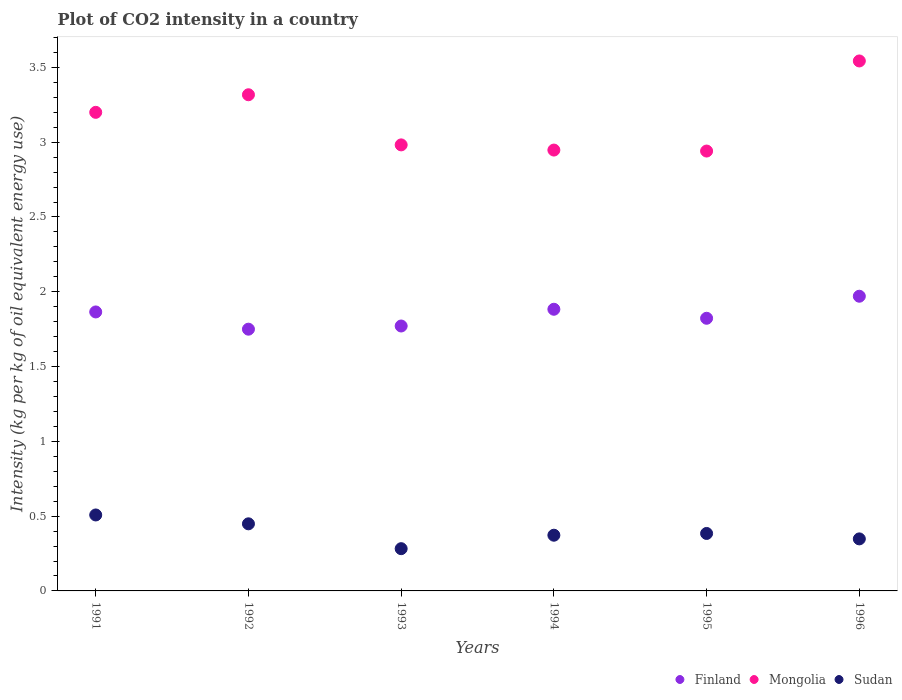How many different coloured dotlines are there?
Ensure brevity in your answer.  3. What is the CO2 intensity in in Sudan in 1992?
Your answer should be compact. 0.45. Across all years, what is the maximum CO2 intensity in in Finland?
Ensure brevity in your answer.  1.97. Across all years, what is the minimum CO2 intensity in in Mongolia?
Ensure brevity in your answer.  2.94. What is the total CO2 intensity in in Finland in the graph?
Your answer should be compact. 11.06. What is the difference between the CO2 intensity in in Sudan in 1991 and that in 1996?
Make the answer very short. 0.16. What is the difference between the CO2 intensity in in Mongolia in 1994 and the CO2 intensity in in Finland in 1996?
Your answer should be compact. 0.98. What is the average CO2 intensity in in Mongolia per year?
Provide a succinct answer. 3.15. In the year 1992, what is the difference between the CO2 intensity in in Mongolia and CO2 intensity in in Finland?
Your response must be concise. 1.57. In how many years, is the CO2 intensity in in Sudan greater than 2.8 kg?
Your answer should be very brief. 0. What is the ratio of the CO2 intensity in in Sudan in 1993 to that in 1995?
Give a very brief answer. 0.74. What is the difference between the highest and the second highest CO2 intensity in in Mongolia?
Keep it short and to the point. 0.23. What is the difference between the highest and the lowest CO2 intensity in in Finland?
Give a very brief answer. 0.22. In how many years, is the CO2 intensity in in Mongolia greater than the average CO2 intensity in in Mongolia taken over all years?
Offer a terse response. 3. Does the CO2 intensity in in Mongolia monotonically increase over the years?
Give a very brief answer. No. How many years are there in the graph?
Offer a terse response. 6. Does the graph contain grids?
Keep it short and to the point. No. How are the legend labels stacked?
Your answer should be very brief. Horizontal. What is the title of the graph?
Your answer should be compact. Plot of CO2 intensity in a country. What is the label or title of the X-axis?
Keep it short and to the point. Years. What is the label or title of the Y-axis?
Provide a succinct answer. Intensity (kg per kg of oil equivalent energy use). What is the Intensity (kg per kg of oil equivalent energy use) of Finland in 1991?
Offer a terse response. 1.87. What is the Intensity (kg per kg of oil equivalent energy use) in Mongolia in 1991?
Your response must be concise. 3.2. What is the Intensity (kg per kg of oil equivalent energy use) in Sudan in 1991?
Your answer should be compact. 0.51. What is the Intensity (kg per kg of oil equivalent energy use) in Finland in 1992?
Provide a succinct answer. 1.75. What is the Intensity (kg per kg of oil equivalent energy use) in Mongolia in 1992?
Give a very brief answer. 3.32. What is the Intensity (kg per kg of oil equivalent energy use) of Sudan in 1992?
Provide a short and direct response. 0.45. What is the Intensity (kg per kg of oil equivalent energy use) of Finland in 1993?
Offer a very short reply. 1.77. What is the Intensity (kg per kg of oil equivalent energy use) of Mongolia in 1993?
Provide a succinct answer. 2.98. What is the Intensity (kg per kg of oil equivalent energy use) of Sudan in 1993?
Keep it short and to the point. 0.28. What is the Intensity (kg per kg of oil equivalent energy use) in Finland in 1994?
Your answer should be compact. 1.88. What is the Intensity (kg per kg of oil equivalent energy use) of Mongolia in 1994?
Offer a very short reply. 2.95. What is the Intensity (kg per kg of oil equivalent energy use) in Sudan in 1994?
Make the answer very short. 0.37. What is the Intensity (kg per kg of oil equivalent energy use) of Finland in 1995?
Your answer should be compact. 1.82. What is the Intensity (kg per kg of oil equivalent energy use) of Mongolia in 1995?
Ensure brevity in your answer.  2.94. What is the Intensity (kg per kg of oil equivalent energy use) of Sudan in 1995?
Provide a short and direct response. 0.38. What is the Intensity (kg per kg of oil equivalent energy use) of Finland in 1996?
Offer a terse response. 1.97. What is the Intensity (kg per kg of oil equivalent energy use) of Mongolia in 1996?
Provide a succinct answer. 3.54. What is the Intensity (kg per kg of oil equivalent energy use) in Sudan in 1996?
Give a very brief answer. 0.35. Across all years, what is the maximum Intensity (kg per kg of oil equivalent energy use) of Finland?
Provide a short and direct response. 1.97. Across all years, what is the maximum Intensity (kg per kg of oil equivalent energy use) of Mongolia?
Give a very brief answer. 3.54. Across all years, what is the maximum Intensity (kg per kg of oil equivalent energy use) in Sudan?
Keep it short and to the point. 0.51. Across all years, what is the minimum Intensity (kg per kg of oil equivalent energy use) in Finland?
Provide a short and direct response. 1.75. Across all years, what is the minimum Intensity (kg per kg of oil equivalent energy use) of Mongolia?
Your answer should be very brief. 2.94. Across all years, what is the minimum Intensity (kg per kg of oil equivalent energy use) in Sudan?
Offer a very short reply. 0.28. What is the total Intensity (kg per kg of oil equivalent energy use) in Finland in the graph?
Make the answer very short. 11.06. What is the total Intensity (kg per kg of oil equivalent energy use) of Mongolia in the graph?
Keep it short and to the point. 18.93. What is the total Intensity (kg per kg of oil equivalent energy use) of Sudan in the graph?
Your answer should be compact. 2.34. What is the difference between the Intensity (kg per kg of oil equivalent energy use) of Finland in 1991 and that in 1992?
Offer a terse response. 0.12. What is the difference between the Intensity (kg per kg of oil equivalent energy use) of Mongolia in 1991 and that in 1992?
Your response must be concise. -0.12. What is the difference between the Intensity (kg per kg of oil equivalent energy use) in Sudan in 1991 and that in 1992?
Your answer should be compact. 0.06. What is the difference between the Intensity (kg per kg of oil equivalent energy use) in Finland in 1991 and that in 1993?
Make the answer very short. 0.09. What is the difference between the Intensity (kg per kg of oil equivalent energy use) of Mongolia in 1991 and that in 1993?
Make the answer very short. 0.22. What is the difference between the Intensity (kg per kg of oil equivalent energy use) in Sudan in 1991 and that in 1993?
Make the answer very short. 0.23. What is the difference between the Intensity (kg per kg of oil equivalent energy use) of Finland in 1991 and that in 1994?
Give a very brief answer. -0.02. What is the difference between the Intensity (kg per kg of oil equivalent energy use) of Mongolia in 1991 and that in 1994?
Your answer should be compact. 0.25. What is the difference between the Intensity (kg per kg of oil equivalent energy use) in Sudan in 1991 and that in 1994?
Your response must be concise. 0.14. What is the difference between the Intensity (kg per kg of oil equivalent energy use) of Finland in 1991 and that in 1995?
Provide a succinct answer. 0.04. What is the difference between the Intensity (kg per kg of oil equivalent energy use) of Mongolia in 1991 and that in 1995?
Keep it short and to the point. 0.26. What is the difference between the Intensity (kg per kg of oil equivalent energy use) in Sudan in 1991 and that in 1995?
Make the answer very short. 0.12. What is the difference between the Intensity (kg per kg of oil equivalent energy use) in Finland in 1991 and that in 1996?
Your answer should be very brief. -0.1. What is the difference between the Intensity (kg per kg of oil equivalent energy use) of Mongolia in 1991 and that in 1996?
Your response must be concise. -0.34. What is the difference between the Intensity (kg per kg of oil equivalent energy use) of Sudan in 1991 and that in 1996?
Make the answer very short. 0.16. What is the difference between the Intensity (kg per kg of oil equivalent energy use) of Finland in 1992 and that in 1993?
Provide a short and direct response. -0.02. What is the difference between the Intensity (kg per kg of oil equivalent energy use) in Mongolia in 1992 and that in 1993?
Keep it short and to the point. 0.34. What is the difference between the Intensity (kg per kg of oil equivalent energy use) of Sudan in 1992 and that in 1993?
Provide a short and direct response. 0.17. What is the difference between the Intensity (kg per kg of oil equivalent energy use) of Finland in 1992 and that in 1994?
Your answer should be very brief. -0.13. What is the difference between the Intensity (kg per kg of oil equivalent energy use) of Mongolia in 1992 and that in 1994?
Ensure brevity in your answer.  0.37. What is the difference between the Intensity (kg per kg of oil equivalent energy use) in Sudan in 1992 and that in 1994?
Provide a succinct answer. 0.08. What is the difference between the Intensity (kg per kg of oil equivalent energy use) of Finland in 1992 and that in 1995?
Your answer should be very brief. -0.07. What is the difference between the Intensity (kg per kg of oil equivalent energy use) in Mongolia in 1992 and that in 1995?
Provide a short and direct response. 0.38. What is the difference between the Intensity (kg per kg of oil equivalent energy use) of Sudan in 1992 and that in 1995?
Offer a very short reply. 0.06. What is the difference between the Intensity (kg per kg of oil equivalent energy use) in Finland in 1992 and that in 1996?
Give a very brief answer. -0.22. What is the difference between the Intensity (kg per kg of oil equivalent energy use) in Mongolia in 1992 and that in 1996?
Provide a short and direct response. -0.23. What is the difference between the Intensity (kg per kg of oil equivalent energy use) in Sudan in 1992 and that in 1996?
Provide a succinct answer. 0.1. What is the difference between the Intensity (kg per kg of oil equivalent energy use) of Finland in 1993 and that in 1994?
Provide a short and direct response. -0.11. What is the difference between the Intensity (kg per kg of oil equivalent energy use) in Mongolia in 1993 and that in 1994?
Offer a very short reply. 0.03. What is the difference between the Intensity (kg per kg of oil equivalent energy use) of Sudan in 1993 and that in 1994?
Make the answer very short. -0.09. What is the difference between the Intensity (kg per kg of oil equivalent energy use) in Finland in 1993 and that in 1995?
Your answer should be very brief. -0.05. What is the difference between the Intensity (kg per kg of oil equivalent energy use) in Mongolia in 1993 and that in 1995?
Ensure brevity in your answer.  0.04. What is the difference between the Intensity (kg per kg of oil equivalent energy use) of Sudan in 1993 and that in 1995?
Keep it short and to the point. -0.1. What is the difference between the Intensity (kg per kg of oil equivalent energy use) of Finland in 1993 and that in 1996?
Your response must be concise. -0.2. What is the difference between the Intensity (kg per kg of oil equivalent energy use) of Mongolia in 1993 and that in 1996?
Keep it short and to the point. -0.56. What is the difference between the Intensity (kg per kg of oil equivalent energy use) of Sudan in 1993 and that in 1996?
Your answer should be compact. -0.07. What is the difference between the Intensity (kg per kg of oil equivalent energy use) in Finland in 1994 and that in 1995?
Offer a very short reply. 0.06. What is the difference between the Intensity (kg per kg of oil equivalent energy use) of Mongolia in 1994 and that in 1995?
Give a very brief answer. 0.01. What is the difference between the Intensity (kg per kg of oil equivalent energy use) of Sudan in 1994 and that in 1995?
Offer a terse response. -0.01. What is the difference between the Intensity (kg per kg of oil equivalent energy use) in Finland in 1994 and that in 1996?
Give a very brief answer. -0.09. What is the difference between the Intensity (kg per kg of oil equivalent energy use) of Mongolia in 1994 and that in 1996?
Offer a very short reply. -0.6. What is the difference between the Intensity (kg per kg of oil equivalent energy use) of Sudan in 1994 and that in 1996?
Ensure brevity in your answer.  0.02. What is the difference between the Intensity (kg per kg of oil equivalent energy use) of Finland in 1995 and that in 1996?
Your response must be concise. -0.15. What is the difference between the Intensity (kg per kg of oil equivalent energy use) in Mongolia in 1995 and that in 1996?
Offer a very short reply. -0.6. What is the difference between the Intensity (kg per kg of oil equivalent energy use) in Sudan in 1995 and that in 1996?
Provide a succinct answer. 0.04. What is the difference between the Intensity (kg per kg of oil equivalent energy use) of Finland in 1991 and the Intensity (kg per kg of oil equivalent energy use) of Mongolia in 1992?
Offer a very short reply. -1.45. What is the difference between the Intensity (kg per kg of oil equivalent energy use) of Finland in 1991 and the Intensity (kg per kg of oil equivalent energy use) of Sudan in 1992?
Your answer should be compact. 1.42. What is the difference between the Intensity (kg per kg of oil equivalent energy use) of Mongolia in 1991 and the Intensity (kg per kg of oil equivalent energy use) of Sudan in 1992?
Give a very brief answer. 2.75. What is the difference between the Intensity (kg per kg of oil equivalent energy use) in Finland in 1991 and the Intensity (kg per kg of oil equivalent energy use) in Mongolia in 1993?
Keep it short and to the point. -1.12. What is the difference between the Intensity (kg per kg of oil equivalent energy use) of Finland in 1991 and the Intensity (kg per kg of oil equivalent energy use) of Sudan in 1993?
Provide a short and direct response. 1.58. What is the difference between the Intensity (kg per kg of oil equivalent energy use) in Mongolia in 1991 and the Intensity (kg per kg of oil equivalent energy use) in Sudan in 1993?
Keep it short and to the point. 2.92. What is the difference between the Intensity (kg per kg of oil equivalent energy use) of Finland in 1991 and the Intensity (kg per kg of oil equivalent energy use) of Mongolia in 1994?
Your answer should be compact. -1.08. What is the difference between the Intensity (kg per kg of oil equivalent energy use) of Finland in 1991 and the Intensity (kg per kg of oil equivalent energy use) of Sudan in 1994?
Offer a terse response. 1.49. What is the difference between the Intensity (kg per kg of oil equivalent energy use) of Mongolia in 1991 and the Intensity (kg per kg of oil equivalent energy use) of Sudan in 1994?
Provide a succinct answer. 2.83. What is the difference between the Intensity (kg per kg of oil equivalent energy use) in Finland in 1991 and the Intensity (kg per kg of oil equivalent energy use) in Mongolia in 1995?
Keep it short and to the point. -1.08. What is the difference between the Intensity (kg per kg of oil equivalent energy use) of Finland in 1991 and the Intensity (kg per kg of oil equivalent energy use) of Sudan in 1995?
Give a very brief answer. 1.48. What is the difference between the Intensity (kg per kg of oil equivalent energy use) of Mongolia in 1991 and the Intensity (kg per kg of oil equivalent energy use) of Sudan in 1995?
Provide a succinct answer. 2.82. What is the difference between the Intensity (kg per kg of oil equivalent energy use) of Finland in 1991 and the Intensity (kg per kg of oil equivalent energy use) of Mongolia in 1996?
Keep it short and to the point. -1.68. What is the difference between the Intensity (kg per kg of oil equivalent energy use) of Finland in 1991 and the Intensity (kg per kg of oil equivalent energy use) of Sudan in 1996?
Make the answer very short. 1.52. What is the difference between the Intensity (kg per kg of oil equivalent energy use) in Mongolia in 1991 and the Intensity (kg per kg of oil equivalent energy use) in Sudan in 1996?
Keep it short and to the point. 2.85. What is the difference between the Intensity (kg per kg of oil equivalent energy use) in Finland in 1992 and the Intensity (kg per kg of oil equivalent energy use) in Mongolia in 1993?
Your response must be concise. -1.23. What is the difference between the Intensity (kg per kg of oil equivalent energy use) in Finland in 1992 and the Intensity (kg per kg of oil equivalent energy use) in Sudan in 1993?
Your response must be concise. 1.47. What is the difference between the Intensity (kg per kg of oil equivalent energy use) of Mongolia in 1992 and the Intensity (kg per kg of oil equivalent energy use) of Sudan in 1993?
Provide a short and direct response. 3.03. What is the difference between the Intensity (kg per kg of oil equivalent energy use) of Finland in 1992 and the Intensity (kg per kg of oil equivalent energy use) of Mongolia in 1994?
Give a very brief answer. -1.2. What is the difference between the Intensity (kg per kg of oil equivalent energy use) in Finland in 1992 and the Intensity (kg per kg of oil equivalent energy use) in Sudan in 1994?
Your response must be concise. 1.38. What is the difference between the Intensity (kg per kg of oil equivalent energy use) of Mongolia in 1992 and the Intensity (kg per kg of oil equivalent energy use) of Sudan in 1994?
Give a very brief answer. 2.94. What is the difference between the Intensity (kg per kg of oil equivalent energy use) of Finland in 1992 and the Intensity (kg per kg of oil equivalent energy use) of Mongolia in 1995?
Ensure brevity in your answer.  -1.19. What is the difference between the Intensity (kg per kg of oil equivalent energy use) of Finland in 1992 and the Intensity (kg per kg of oil equivalent energy use) of Sudan in 1995?
Provide a succinct answer. 1.37. What is the difference between the Intensity (kg per kg of oil equivalent energy use) of Mongolia in 1992 and the Intensity (kg per kg of oil equivalent energy use) of Sudan in 1995?
Provide a short and direct response. 2.93. What is the difference between the Intensity (kg per kg of oil equivalent energy use) of Finland in 1992 and the Intensity (kg per kg of oil equivalent energy use) of Mongolia in 1996?
Offer a terse response. -1.79. What is the difference between the Intensity (kg per kg of oil equivalent energy use) in Finland in 1992 and the Intensity (kg per kg of oil equivalent energy use) in Sudan in 1996?
Make the answer very short. 1.4. What is the difference between the Intensity (kg per kg of oil equivalent energy use) of Mongolia in 1992 and the Intensity (kg per kg of oil equivalent energy use) of Sudan in 1996?
Your answer should be very brief. 2.97. What is the difference between the Intensity (kg per kg of oil equivalent energy use) in Finland in 1993 and the Intensity (kg per kg of oil equivalent energy use) in Mongolia in 1994?
Give a very brief answer. -1.18. What is the difference between the Intensity (kg per kg of oil equivalent energy use) in Finland in 1993 and the Intensity (kg per kg of oil equivalent energy use) in Sudan in 1994?
Ensure brevity in your answer.  1.4. What is the difference between the Intensity (kg per kg of oil equivalent energy use) of Mongolia in 1993 and the Intensity (kg per kg of oil equivalent energy use) of Sudan in 1994?
Your answer should be very brief. 2.61. What is the difference between the Intensity (kg per kg of oil equivalent energy use) of Finland in 1993 and the Intensity (kg per kg of oil equivalent energy use) of Mongolia in 1995?
Your response must be concise. -1.17. What is the difference between the Intensity (kg per kg of oil equivalent energy use) in Finland in 1993 and the Intensity (kg per kg of oil equivalent energy use) in Sudan in 1995?
Offer a very short reply. 1.39. What is the difference between the Intensity (kg per kg of oil equivalent energy use) of Mongolia in 1993 and the Intensity (kg per kg of oil equivalent energy use) of Sudan in 1995?
Make the answer very short. 2.6. What is the difference between the Intensity (kg per kg of oil equivalent energy use) of Finland in 1993 and the Intensity (kg per kg of oil equivalent energy use) of Mongolia in 1996?
Make the answer very short. -1.77. What is the difference between the Intensity (kg per kg of oil equivalent energy use) in Finland in 1993 and the Intensity (kg per kg of oil equivalent energy use) in Sudan in 1996?
Make the answer very short. 1.42. What is the difference between the Intensity (kg per kg of oil equivalent energy use) in Mongolia in 1993 and the Intensity (kg per kg of oil equivalent energy use) in Sudan in 1996?
Offer a very short reply. 2.63. What is the difference between the Intensity (kg per kg of oil equivalent energy use) in Finland in 1994 and the Intensity (kg per kg of oil equivalent energy use) in Mongolia in 1995?
Provide a short and direct response. -1.06. What is the difference between the Intensity (kg per kg of oil equivalent energy use) in Finland in 1994 and the Intensity (kg per kg of oil equivalent energy use) in Sudan in 1995?
Give a very brief answer. 1.5. What is the difference between the Intensity (kg per kg of oil equivalent energy use) of Mongolia in 1994 and the Intensity (kg per kg of oil equivalent energy use) of Sudan in 1995?
Make the answer very short. 2.56. What is the difference between the Intensity (kg per kg of oil equivalent energy use) in Finland in 1994 and the Intensity (kg per kg of oil equivalent energy use) in Mongolia in 1996?
Ensure brevity in your answer.  -1.66. What is the difference between the Intensity (kg per kg of oil equivalent energy use) in Finland in 1994 and the Intensity (kg per kg of oil equivalent energy use) in Sudan in 1996?
Provide a short and direct response. 1.54. What is the difference between the Intensity (kg per kg of oil equivalent energy use) of Mongolia in 1994 and the Intensity (kg per kg of oil equivalent energy use) of Sudan in 1996?
Your answer should be compact. 2.6. What is the difference between the Intensity (kg per kg of oil equivalent energy use) of Finland in 1995 and the Intensity (kg per kg of oil equivalent energy use) of Mongolia in 1996?
Offer a very short reply. -1.72. What is the difference between the Intensity (kg per kg of oil equivalent energy use) of Finland in 1995 and the Intensity (kg per kg of oil equivalent energy use) of Sudan in 1996?
Your response must be concise. 1.47. What is the difference between the Intensity (kg per kg of oil equivalent energy use) of Mongolia in 1995 and the Intensity (kg per kg of oil equivalent energy use) of Sudan in 1996?
Keep it short and to the point. 2.59. What is the average Intensity (kg per kg of oil equivalent energy use) in Finland per year?
Keep it short and to the point. 1.84. What is the average Intensity (kg per kg of oil equivalent energy use) in Mongolia per year?
Offer a very short reply. 3.15. What is the average Intensity (kg per kg of oil equivalent energy use) of Sudan per year?
Give a very brief answer. 0.39. In the year 1991, what is the difference between the Intensity (kg per kg of oil equivalent energy use) of Finland and Intensity (kg per kg of oil equivalent energy use) of Mongolia?
Keep it short and to the point. -1.33. In the year 1991, what is the difference between the Intensity (kg per kg of oil equivalent energy use) of Finland and Intensity (kg per kg of oil equivalent energy use) of Sudan?
Your answer should be compact. 1.36. In the year 1991, what is the difference between the Intensity (kg per kg of oil equivalent energy use) of Mongolia and Intensity (kg per kg of oil equivalent energy use) of Sudan?
Provide a succinct answer. 2.69. In the year 1992, what is the difference between the Intensity (kg per kg of oil equivalent energy use) of Finland and Intensity (kg per kg of oil equivalent energy use) of Mongolia?
Keep it short and to the point. -1.57. In the year 1992, what is the difference between the Intensity (kg per kg of oil equivalent energy use) of Finland and Intensity (kg per kg of oil equivalent energy use) of Sudan?
Offer a very short reply. 1.3. In the year 1992, what is the difference between the Intensity (kg per kg of oil equivalent energy use) of Mongolia and Intensity (kg per kg of oil equivalent energy use) of Sudan?
Your response must be concise. 2.87. In the year 1993, what is the difference between the Intensity (kg per kg of oil equivalent energy use) of Finland and Intensity (kg per kg of oil equivalent energy use) of Mongolia?
Your answer should be very brief. -1.21. In the year 1993, what is the difference between the Intensity (kg per kg of oil equivalent energy use) of Finland and Intensity (kg per kg of oil equivalent energy use) of Sudan?
Give a very brief answer. 1.49. In the year 1993, what is the difference between the Intensity (kg per kg of oil equivalent energy use) of Mongolia and Intensity (kg per kg of oil equivalent energy use) of Sudan?
Give a very brief answer. 2.7. In the year 1994, what is the difference between the Intensity (kg per kg of oil equivalent energy use) in Finland and Intensity (kg per kg of oil equivalent energy use) in Mongolia?
Keep it short and to the point. -1.06. In the year 1994, what is the difference between the Intensity (kg per kg of oil equivalent energy use) in Finland and Intensity (kg per kg of oil equivalent energy use) in Sudan?
Offer a terse response. 1.51. In the year 1994, what is the difference between the Intensity (kg per kg of oil equivalent energy use) of Mongolia and Intensity (kg per kg of oil equivalent energy use) of Sudan?
Your answer should be very brief. 2.57. In the year 1995, what is the difference between the Intensity (kg per kg of oil equivalent energy use) in Finland and Intensity (kg per kg of oil equivalent energy use) in Mongolia?
Provide a short and direct response. -1.12. In the year 1995, what is the difference between the Intensity (kg per kg of oil equivalent energy use) of Finland and Intensity (kg per kg of oil equivalent energy use) of Sudan?
Your response must be concise. 1.44. In the year 1995, what is the difference between the Intensity (kg per kg of oil equivalent energy use) of Mongolia and Intensity (kg per kg of oil equivalent energy use) of Sudan?
Your response must be concise. 2.56. In the year 1996, what is the difference between the Intensity (kg per kg of oil equivalent energy use) of Finland and Intensity (kg per kg of oil equivalent energy use) of Mongolia?
Your answer should be compact. -1.57. In the year 1996, what is the difference between the Intensity (kg per kg of oil equivalent energy use) in Finland and Intensity (kg per kg of oil equivalent energy use) in Sudan?
Make the answer very short. 1.62. In the year 1996, what is the difference between the Intensity (kg per kg of oil equivalent energy use) of Mongolia and Intensity (kg per kg of oil equivalent energy use) of Sudan?
Your answer should be compact. 3.2. What is the ratio of the Intensity (kg per kg of oil equivalent energy use) in Finland in 1991 to that in 1992?
Give a very brief answer. 1.07. What is the ratio of the Intensity (kg per kg of oil equivalent energy use) of Mongolia in 1991 to that in 1992?
Your answer should be very brief. 0.96. What is the ratio of the Intensity (kg per kg of oil equivalent energy use) of Sudan in 1991 to that in 1992?
Provide a short and direct response. 1.13. What is the ratio of the Intensity (kg per kg of oil equivalent energy use) in Finland in 1991 to that in 1993?
Provide a succinct answer. 1.05. What is the ratio of the Intensity (kg per kg of oil equivalent energy use) of Mongolia in 1991 to that in 1993?
Offer a terse response. 1.07. What is the ratio of the Intensity (kg per kg of oil equivalent energy use) in Sudan in 1991 to that in 1993?
Ensure brevity in your answer.  1.8. What is the ratio of the Intensity (kg per kg of oil equivalent energy use) in Mongolia in 1991 to that in 1994?
Provide a succinct answer. 1.09. What is the ratio of the Intensity (kg per kg of oil equivalent energy use) in Sudan in 1991 to that in 1994?
Offer a very short reply. 1.36. What is the ratio of the Intensity (kg per kg of oil equivalent energy use) of Finland in 1991 to that in 1995?
Make the answer very short. 1.02. What is the ratio of the Intensity (kg per kg of oil equivalent energy use) of Mongolia in 1991 to that in 1995?
Your answer should be compact. 1.09. What is the ratio of the Intensity (kg per kg of oil equivalent energy use) of Sudan in 1991 to that in 1995?
Offer a terse response. 1.32. What is the ratio of the Intensity (kg per kg of oil equivalent energy use) in Finland in 1991 to that in 1996?
Provide a succinct answer. 0.95. What is the ratio of the Intensity (kg per kg of oil equivalent energy use) of Mongolia in 1991 to that in 1996?
Offer a terse response. 0.9. What is the ratio of the Intensity (kg per kg of oil equivalent energy use) in Sudan in 1991 to that in 1996?
Provide a succinct answer. 1.46. What is the ratio of the Intensity (kg per kg of oil equivalent energy use) in Mongolia in 1992 to that in 1993?
Your answer should be compact. 1.11. What is the ratio of the Intensity (kg per kg of oil equivalent energy use) in Sudan in 1992 to that in 1993?
Give a very brief answer. 1.59. What is the ratio of the Intensity (kg per kg of oil equivalent energy use) of Finland in 1992 to that in 1994?
Keep it short and to the point. 0.93. What is the ratio of the Intensity (kg per kg of oil equivalent energy use) in Mongolia in 1992 to that in 1994?
Give a very brief answer. 1.13. What is the ratio of the Intensity (kg per kg of oil equivalent energy use) in Sudan in 1992 to that in 1994?
Offer a very short reply. 1.2. What is the ratio of the Intensity (kg per kg of oil equivalent energy use) of Mongolia in 1992 to that in 1995?
Offer a terse response. 1.13. What is the ratio of the Intensity (kg per kg of oil equivalent energy use) in Sudan in 1992 to that in 1995?
Your answer should be very brief. 1.17. What is the ratio of the Intensity (kg per kg of oil equivalent energy use) in Finland in 1992 to that in 1996?
Provide a short and direct response. 0.89. What is the ratio of the Intensity (kg per kg of oil equivalent energy use) of Mongolia in 1992 to that in 1996?
Give a very brief answer. 0.94. What is the ratio of the Intensity (kg per kg of oil equivalent energy use) in Sudan in 1992 to that in 1996?
Provide a short and direct response. 1.29. What is the ratio of the Intensity (kg per kg of oil equivalent energy use) of Finland in 1993 to that in 1994?
Keep it short and to the point. 0.94. What is the ratio of the Intensity (kg per kg of oil equivalent energy use) in Mongolia in 1993 to that in 1994?
Your response must be concise. 1.01. What is the ratio of the Intensity (kg per kg of oil equivalent energy use) of Sudan in 1993 to that in 1994?
Provide a short and direct response. 0.76. What is the ratio of the Intensity (kg per kg of oil equivalent energy use) of Finland in 1993 to that in 1995?
Your answer should be compact. 0.97. What is the ratio of the Intensity (kg per kg of oil equivalent energy use) in Sudan in 1993 to that in 1995?
Ensure brevity in your answer.  0.74. What is the ratio of the Intensity (kg per kg of oil equivalent energy use) in Finland in 1993 to that in 1996?
Provide a short and direct response. 0.9. What is the ratio of the Intensity (kg per kg of oil equivalent energy use) in Mongolia in 1993 to that in 1996?
Offer a very short reply. 0.84. What is the ratio of the Intensity (kg per kg of oil equivalent energy use) in Sudan in 1993 to that in 1996?
Keep it short and to the point. 0.81. What is the ratio of the Intensity (kg per kg of oil equivalent energy use) of Finland in 1994 to that in 1995?
Offer a terse response. 1.03. What is the ratio of the Intensity (kg per kg of oil equivalent energy use) of Mongolia in 1994 to that in 1995?
Your answer should be very brief. 1. What is the ratio of the Intensity (kg per kg of oil equivalent energy use) of Sudan in 1994 to that in 1995?
Give a very brief answer. 0.97. What is the ratio of the Intensity (kg per kg of oil equivalent energy use) of Finland in 1994 to that in 1996?
Your answer should be compact. 0.96. What is the ratio of the Intensity (kg per kg of oil equivalent energy use) in Mongolia in 1994 to that in 1996?
Your answer should be very brief. 0.83. What is the ratio of the Intensity (kg per kg of oil equivalent energy use) in Sudan in 1994 to that in 1996?
Your answer should be very brief. 1.07. What is the ratio of the Intensity (kg per kg of oil equivalent energy use) in Finland in 1995 to that in 1996?
Give a very brief answer. 0.93. What is the ratio of the Intensity (kg per kg of oil equivalent energy use) in Mongolia in 1995 to that in 1996?
Provide a succinct answer. 0.83. What is the ratio of the Intensity (kg per kg of oil equivalent energy use) in Sudan in 1995 to that in 1996?
Your response must be concise. 1.1. What is the difference between the highest and the second highest Intensity (kg per kg of oil equivalent energy use) of Finland?
Make the answer very short. 0.09. What is the difference between the highest and the second highest Intensity (kg per kg of oil equivalent energy use) in Mongolia?
Give a very brief answer. 0.23. What is the difference between the highest and the second highest Intensity (kg per kg of oil equivalent energy use) in Sudan?
Provide a short and direct response. 0.06. What is the difference between the highest and the lowest Intensity (kg per kg of oil equivalent energy use) in Finland?
Your answer should be very brief. 0.22. What is the difference between the highest and the lowest Intensity (kg per kg of oil equivalent energy use) of Mongolia?
Offer a very short reply. 0.6. What is the difference between the highest and the lowest Intensity (kg per kg of oil equivalent energy use) of Sudan?
Offer a very short reply. 0.23. 